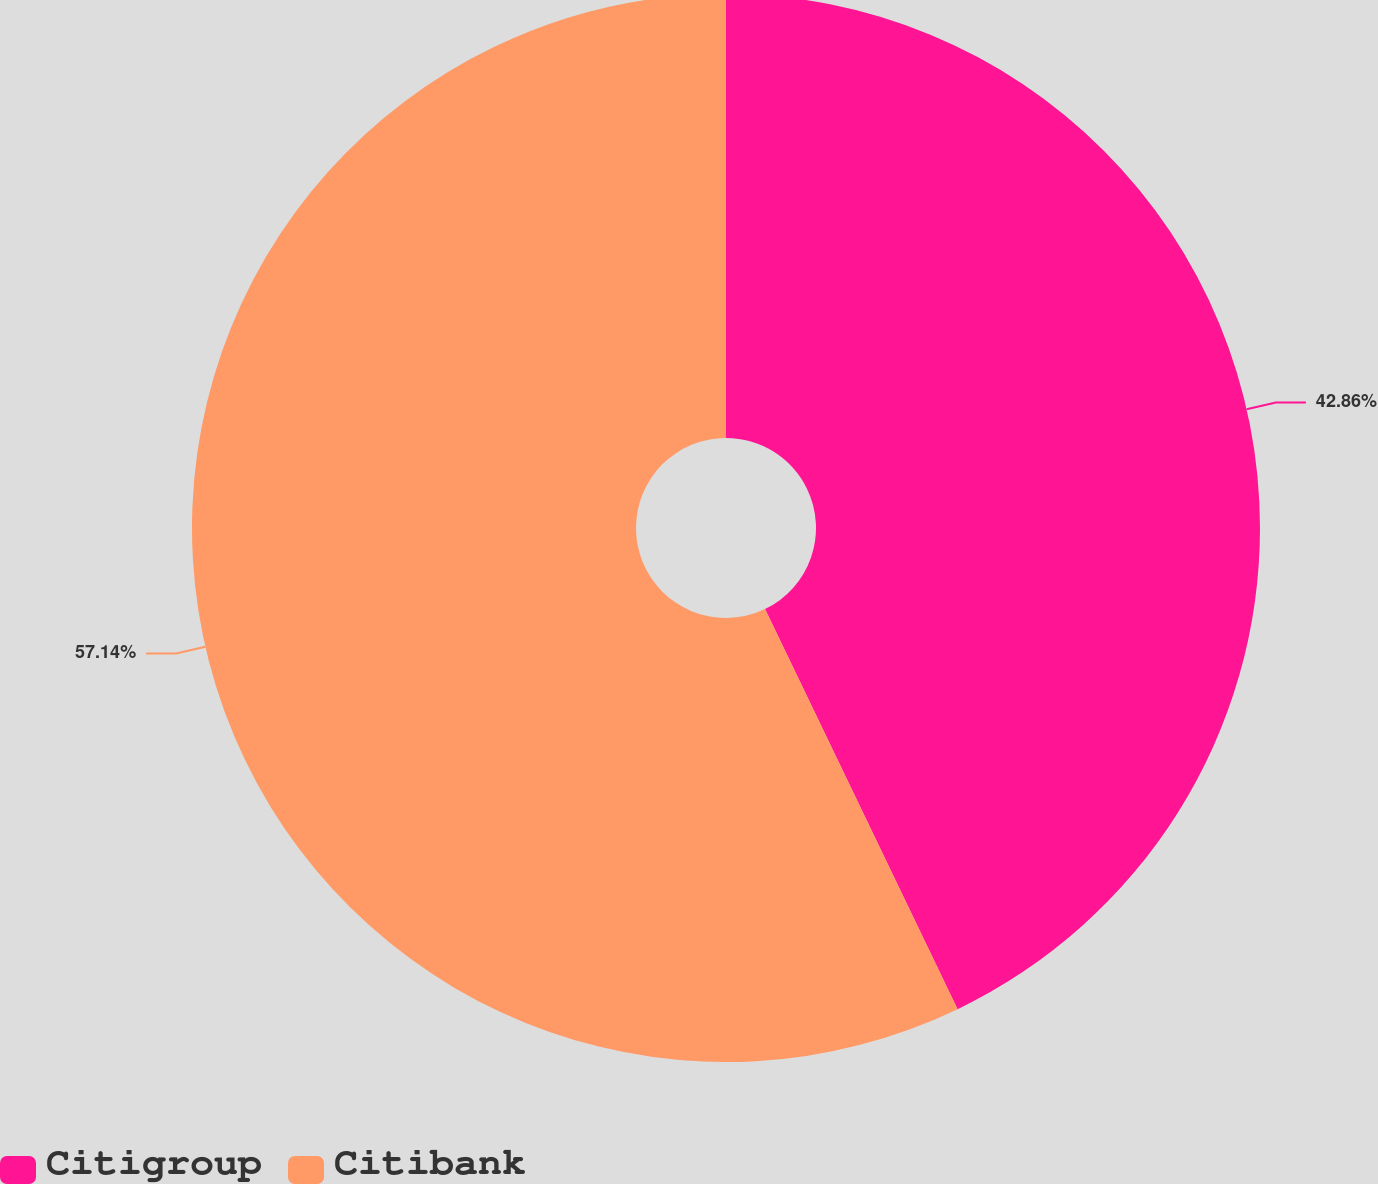<chart> <loc_0><loc_0><loc_500><loc_500><pie_chart><fcel>Citigroup<fcel>Citibank<nl><fcel>42.86%<fcel>57.14%<nl></chart> 